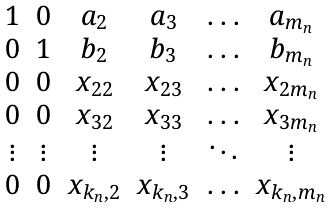<formula> <loc_0><loc_0><loc_500><loc_500>\begin{matrix} 1 & 0 & a _ { 2 } & a _ { 3 } & \hdots & a _ { m _ { n } } \\ 0 & 1 & b _ { 2 } & b _ { 3 } & \hdots & b _ { m _ { n } } \\ 0 & 0 & x _ { 2 2 } & x _ { 2 3 } & \hdots & x _ { 2 m _ { n } } \\ 0 & 0 & x _ { 3 2 } & x _ { 3 3 } & \hdots & x _ { 3 m _ { n } } \\ \vdots & \vdots & \vdots & \vdots & \ddots & \vdots \\ 0 & 0 & x _ { k _ { n } , 2 } & x _ { k _ { n } , 3 } & \hdots & x _ { k _ { n } , m _ { n } } \end{matrix}</formula> 